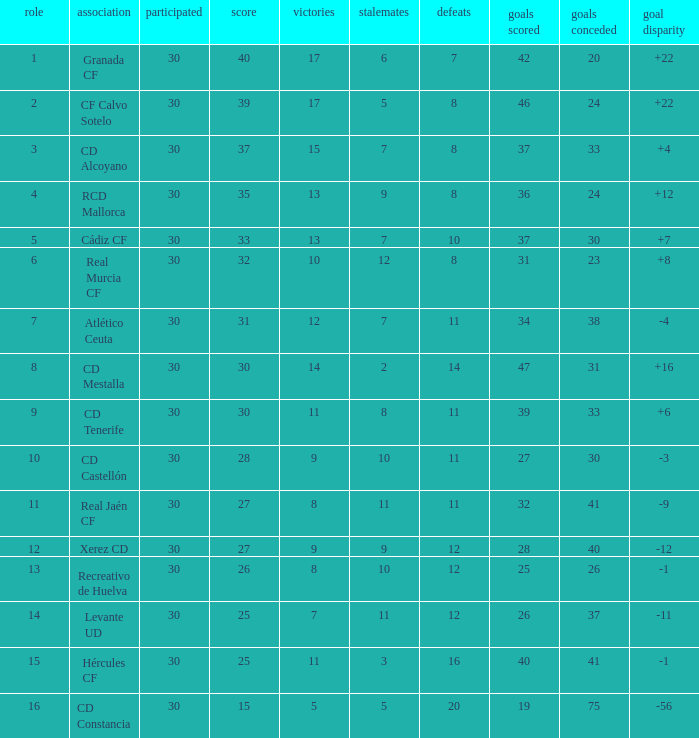Which Wins have a Goal Difference larger than 12, and a Club of granada cf, and Played larger than 30? None. 